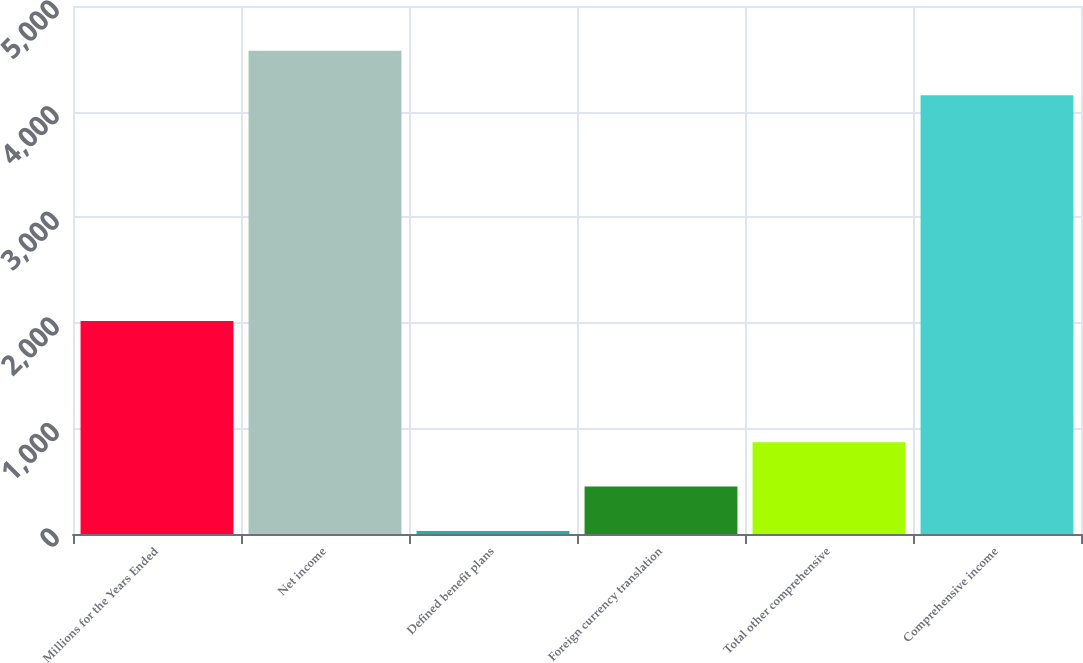Convert chart to OTSL. <chart><loc_0><loc_0><loc_500><loc_500><bar_chart><fcel>Millions for the Years Ended<fcel>Net income<fcel>Defined benefit plans<fcel>Foreign currency translation<fcel>Total other comprehensive<fcel>Comprehensive income<nl><fcel>2016<fcel>4576.4<fcel>29<fcel>449.4<fcel>869.8<fcel>4156<nl></chart> 